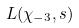<formula> <loc_0><loc_0><loc_500><loc_500>L ( \chi _ { - 3 } , s )</formula> 